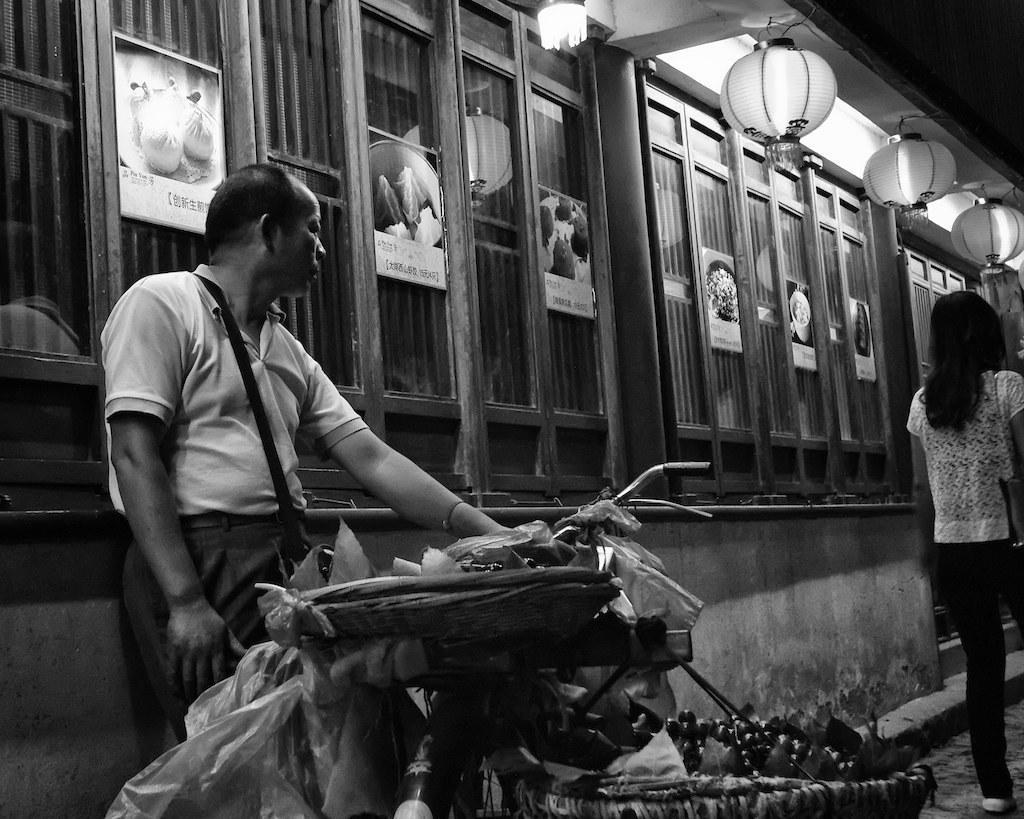Please provide a concise description of this image. In this picture there is a man standing and holding the bicycle and there are fruits in the baskets and there is a woman walking. At the back there are boards on the wall. At the top there are lights. At the bottom there is a road. 